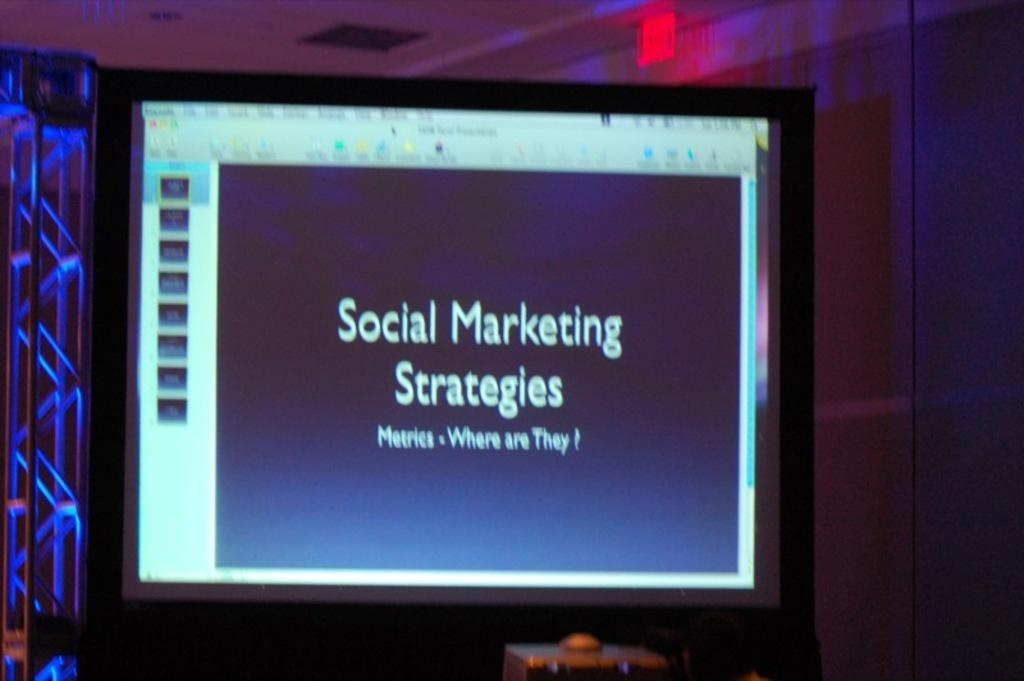<image>
Give a short and clear explanation of the subsequent image. A monitor mentions social marketing strategies and metrics. 